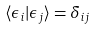<formula> <loc_0><loc_0><loc_500><loc_500>\langle \epsilon _ { i } | \epsilon _ { j } \rangle = \delta _ { i j }</formula> 